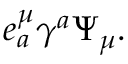<formula> <loc_0><loc_0><loc_500><loc_500>e _ { a } ^ { \mu } \gamma ^ { a } \Psi _ { \mu } .</formula> 